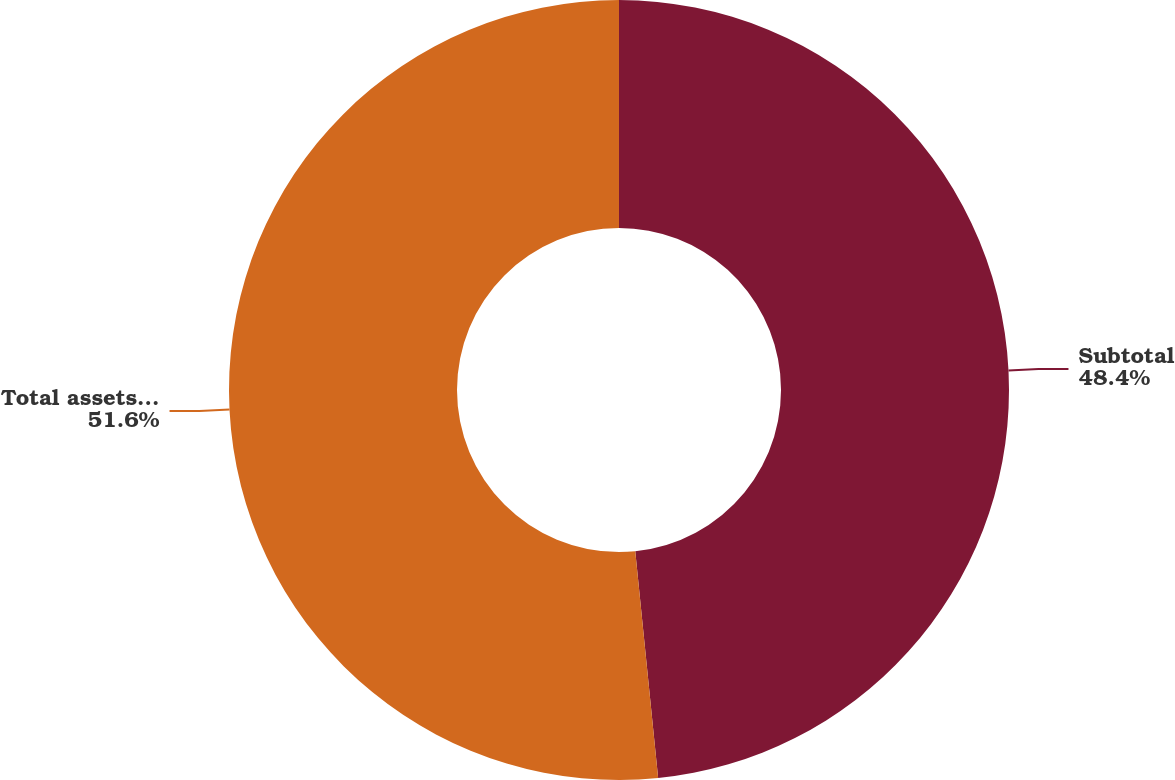<chart> <loc_0><loc_0><loc_500><loc_500><pie_chart><fcel>Subtotal<fcel>Total assets measured at fair<nl><fcel>48.4%<fcel>51.6%<nl></chart> 